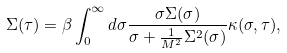Convert formula to latex. <formula><loc_0><loc_0><loc_500><loc_500>\Sigma ( \tau ) = \beta \int _ { 0 } ^ { \infty } d \sigma \frac { \sigma \Sigma ( \sigma ) } { \sigma + \frac { 1 } { M ^ { 2 } } \Sigma ^ { 2 } ( \sigma ) } \kappa ( \sigma , \tau ) ,</formula> 